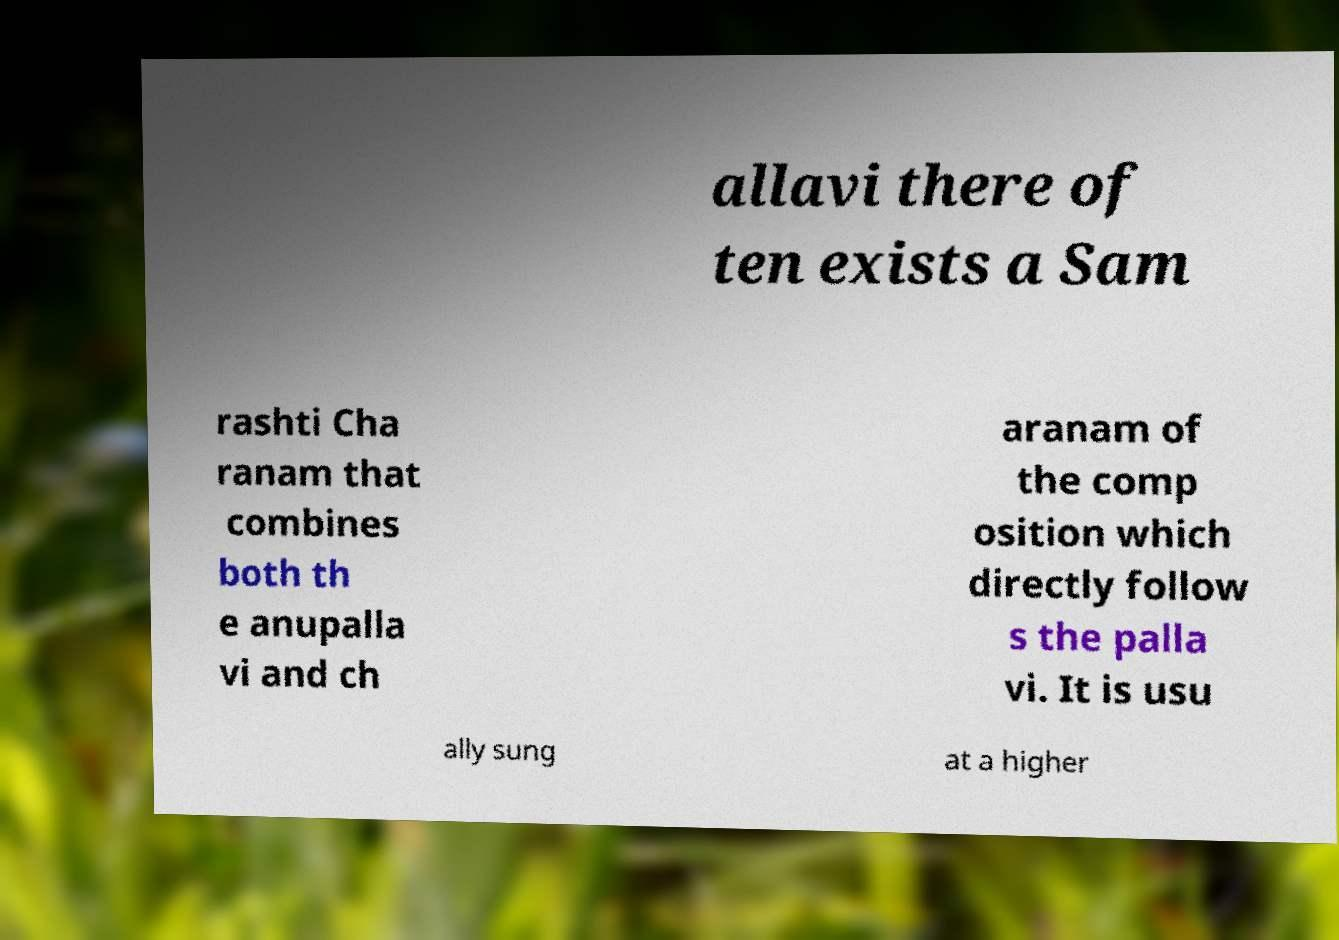Can you read and provide the text displayed in the image?This photo seems to have some interesting text. Can you extract and type it out for me? allavi there of ten exists a Sam rashti Cha ranam that combines both th e anupalla vi and ch aranam of the comp osition which directly follow s the palla vi. It is usu ally sung at a higher 